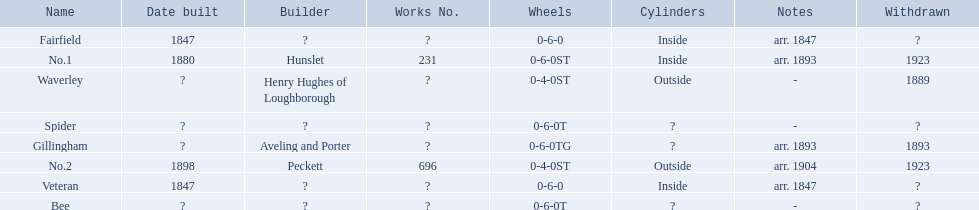What are the alderney railway names? Veteran, Fairfield, Waverley, Bee, Spider, Gillingham, No.1, No.2. When was the farfield built? 1847. What else was built that year? Veteran. 